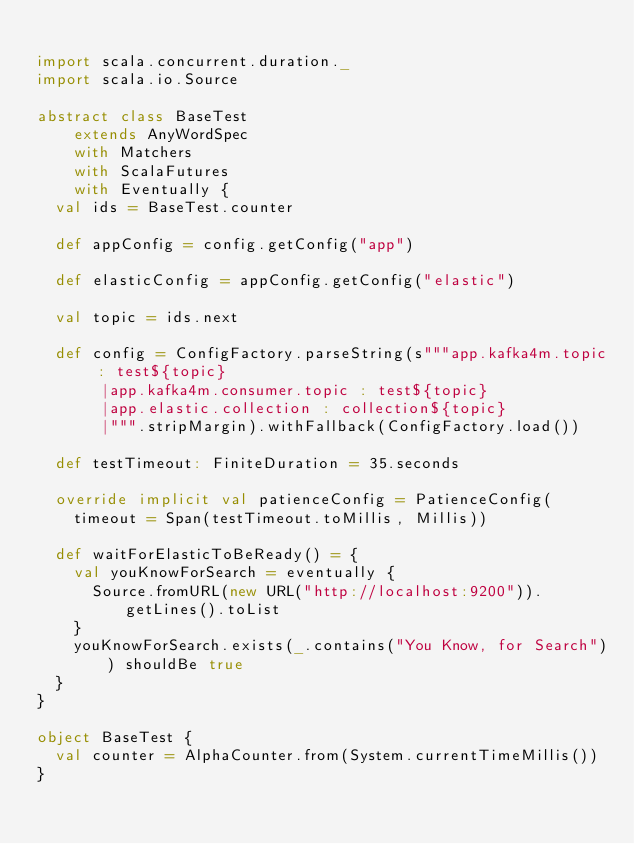Convert code to text. <code><loc_0><loc_0><loc_500><loc_500><_Scala_>
import scala.concurrent.duration._
import scala.io.Source

abstract class BaseTest
    extends AnyWordSpec
    with Matchers
    with ScalaFutures
    with Eventually {
  val ids = BaseTest.counter

  def appConfig = config.getConfig("app")

  def elasticConfig = appConfig.getConfig("elastic")

  val topic = ids.next

  def config = ConfigFactory.parseString(s"""app.kafka4m.topic : test${topic}
       |app.kafka4m.consumer.topic : test${topic}
       |app.elastic.collection : collection${topic}
       |""".stripMargin).withFallback(ConfigFactory.load())

  def testTimeout: FiniteDuration = 35.seconds

  override implicit val patienceConfig = PatienceConfig(
    timeout = Span(testTimeout.toMillis, Millis))

  def waitForElasticToBeReady() = {
    val youKnowForSearch = eventually {
      Source.fromURL(new URL("http://localhost:9200")).getLines().toList
    }
    youKnowForSearch.exists(_.contains("You Know, for Search")) shouldBe true
  }
}

object BaseTest {
  val counter = AlphaCounter.from(System.currentTimeMillis())
}
</code> 